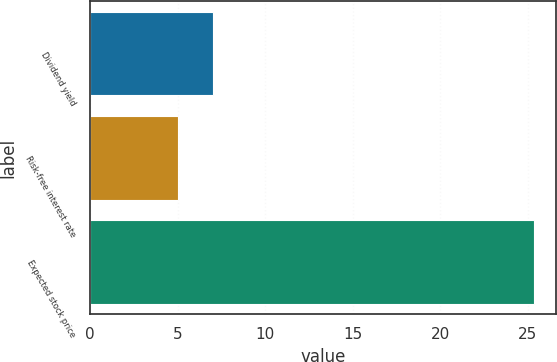Convert chart. <chart><loc_0><loc_0><loc_500><loc_500><bar_chart><fcel>Dividend yield<fcel>Risk-free interest rate<fcel>Expected stock price<nl><fcel>7.04<fcel>5<fcel>25.35<nl></chart> 